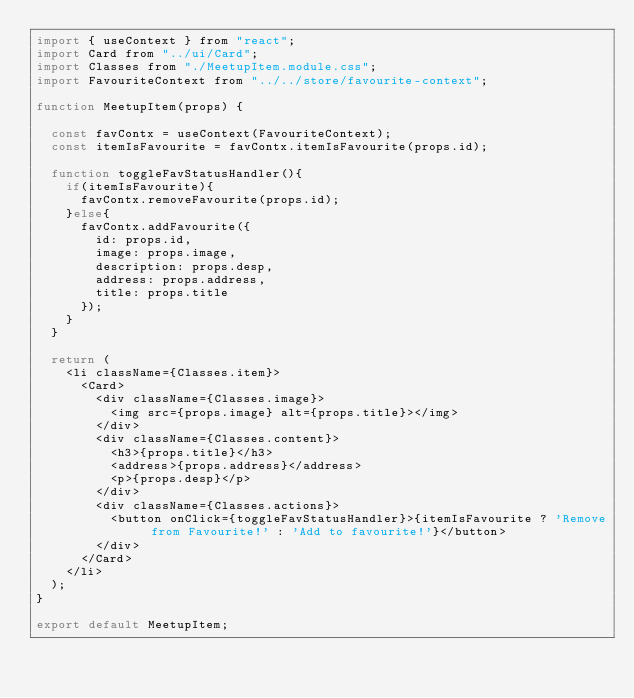Convert code to text. <code><loc_0><loc_0><loc_500><loc_500><_JavaScript_>import { useContext } from "react";
import Card from "../ui/Card";
import Classes from "./MeetupItem.module.css";
import FavouriteContext from "../../store/favourite-context";

function MeetupItem(props) {

  const favContx = useContext(FavouriteContext);
  const itemIsFavourite = favContx.itemIsFavourite(props.id);

  function toggleFavStatusHandler(){
    if(itemIsFavourite){
      favContx.removeFavourite(props.id);
    }else{
      favContx.addFavourite({
        id: props.id,
        image: props.image,
        description: props.desp,
        address: props.address,
        title: props.title
      });
    }
  }

  return (
    <li className={Classes.item}>
      <Card>
        <div className={Classes.image}>
          <img src={props.image} alt={props.title}></img>
        </div>
        <div className={Classes.content}>
          <h3>{props.title}</h3>
          <address>{props.address}</address>
          <p>{props.desp}</p>
        </div>
        <div className={Classes.actions}>
          <button onClick={toggleFavStatusHandler}>{itemIsFavourite ? 'Remove from Favourite!' : 'Add to favourite!'}</button>
        </div>
      </Card>
    </li>
  );
}

export default MeetupItem;
</code> 